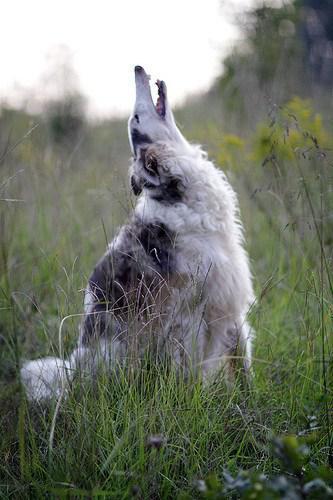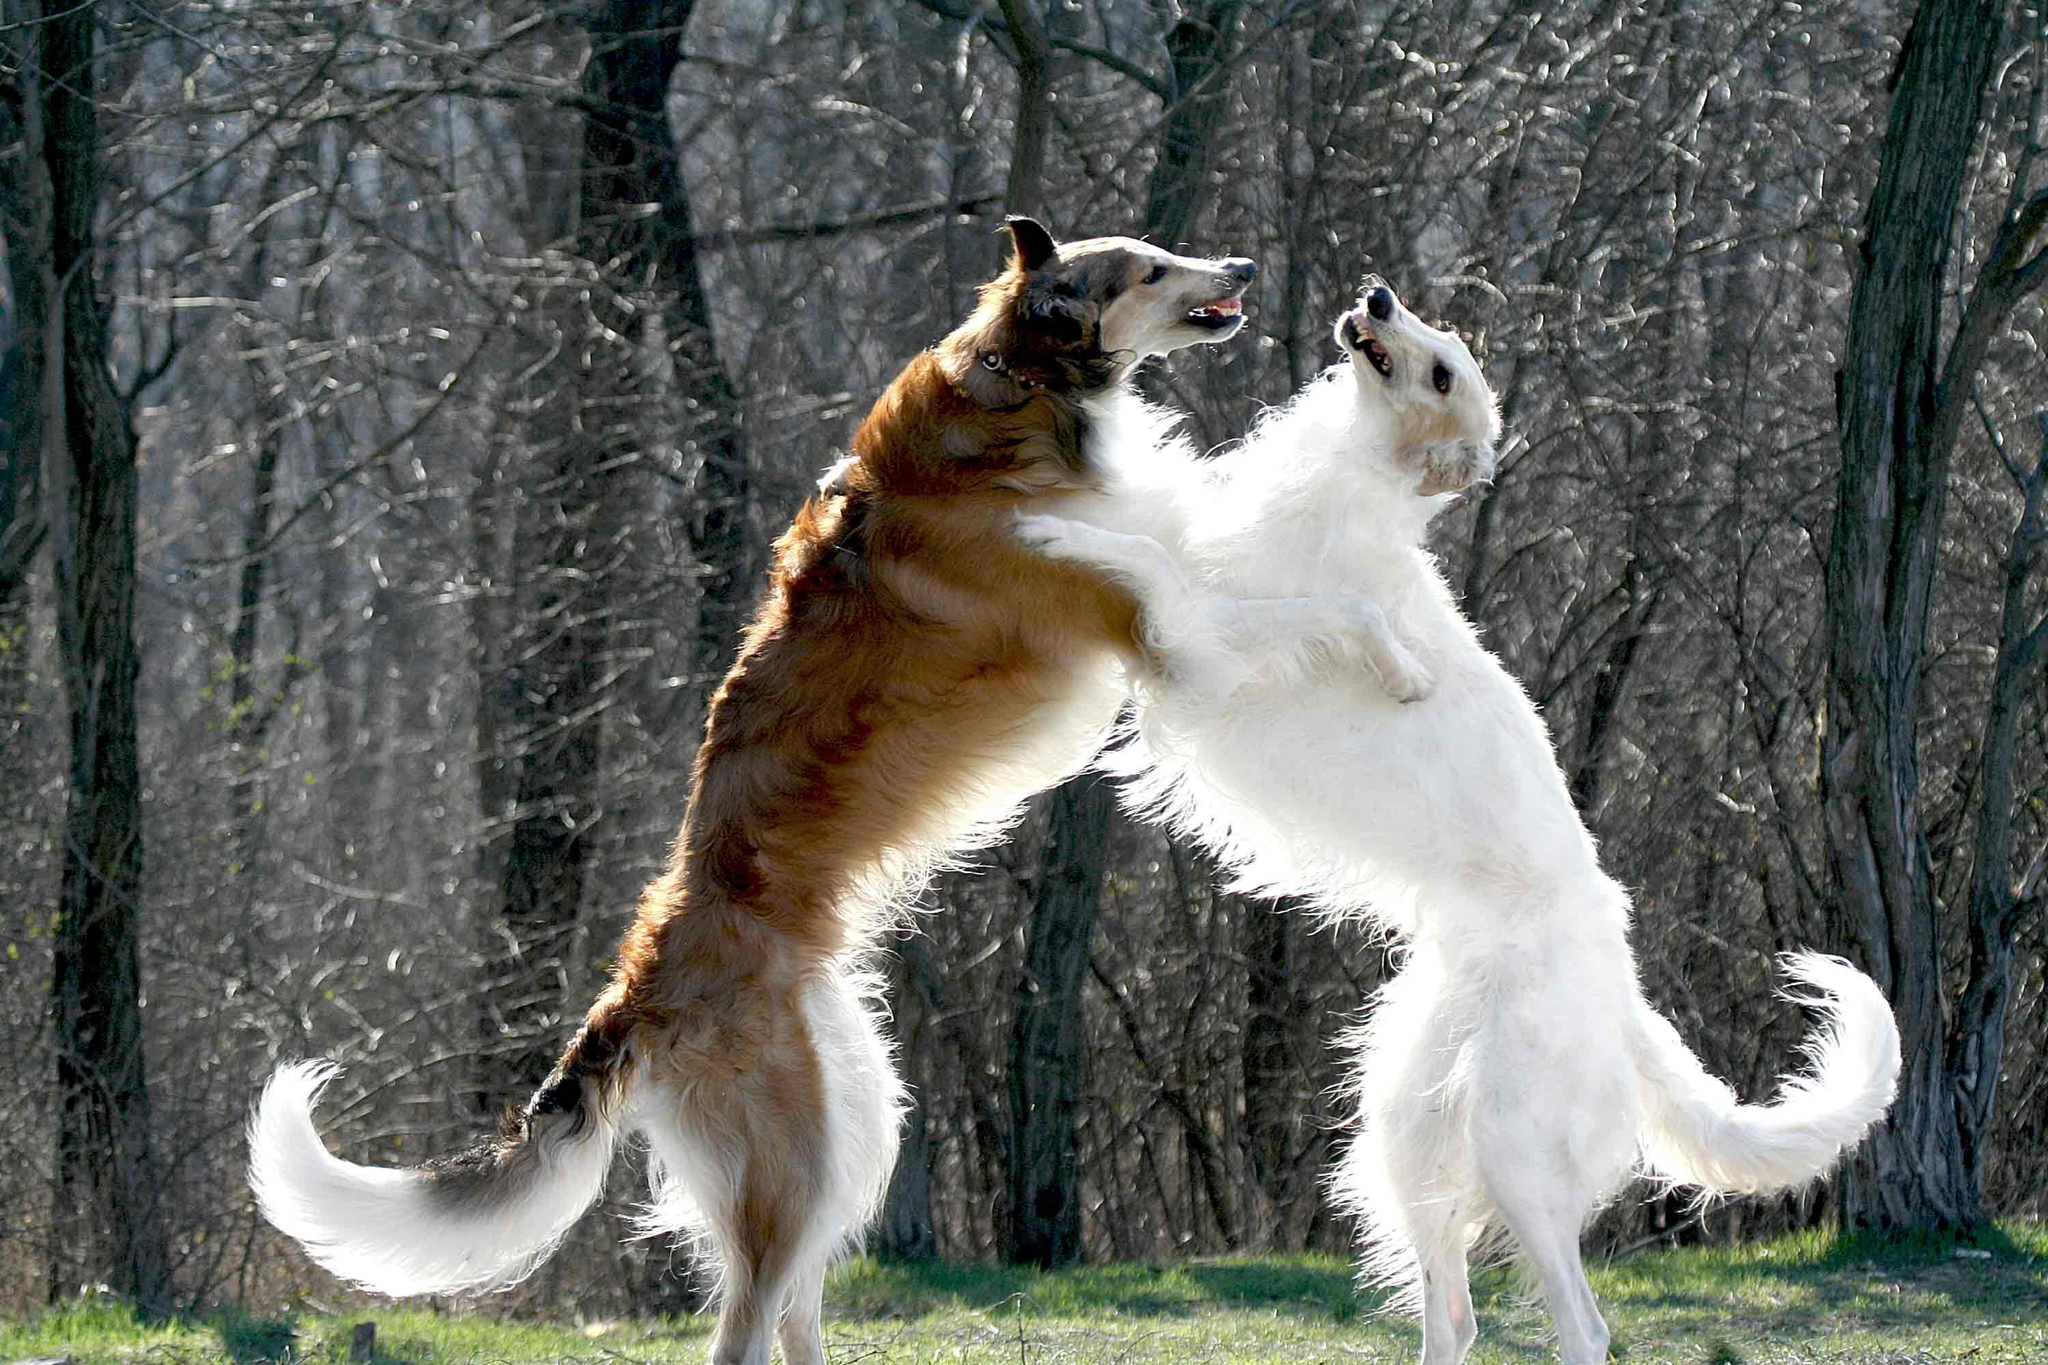The first image is the image on the left, the second image is the image on the right. For the images shown, is this caption "An image shows two hounds interacting face-to-face." true? Answer yes or no. Yes. The first image is the image on the left, the second image is the image on the right. For the images shown, is this caption "Two dogs are facing each other in one of the images." true? Answer yes or no. Yes. 